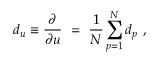Convert formula to latex. <formula><loc_0><loc_0><loc_500><loc_500>d _ { u } \equiv \frac { \partial } { \partial u } \ = \ \frac { 1 } { N } \sum _ { p = 1 } ^ { N } d _ { p } \ ,</formula> 